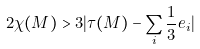Convert formula to latex. <formula><loc_0><loc_0><loc_500><loc_500>2 \chi ( M ) > 3 | \tau ( M ) - \sum _ { i } \frac { 1 } { 3 } e _ { i } |</formula> 